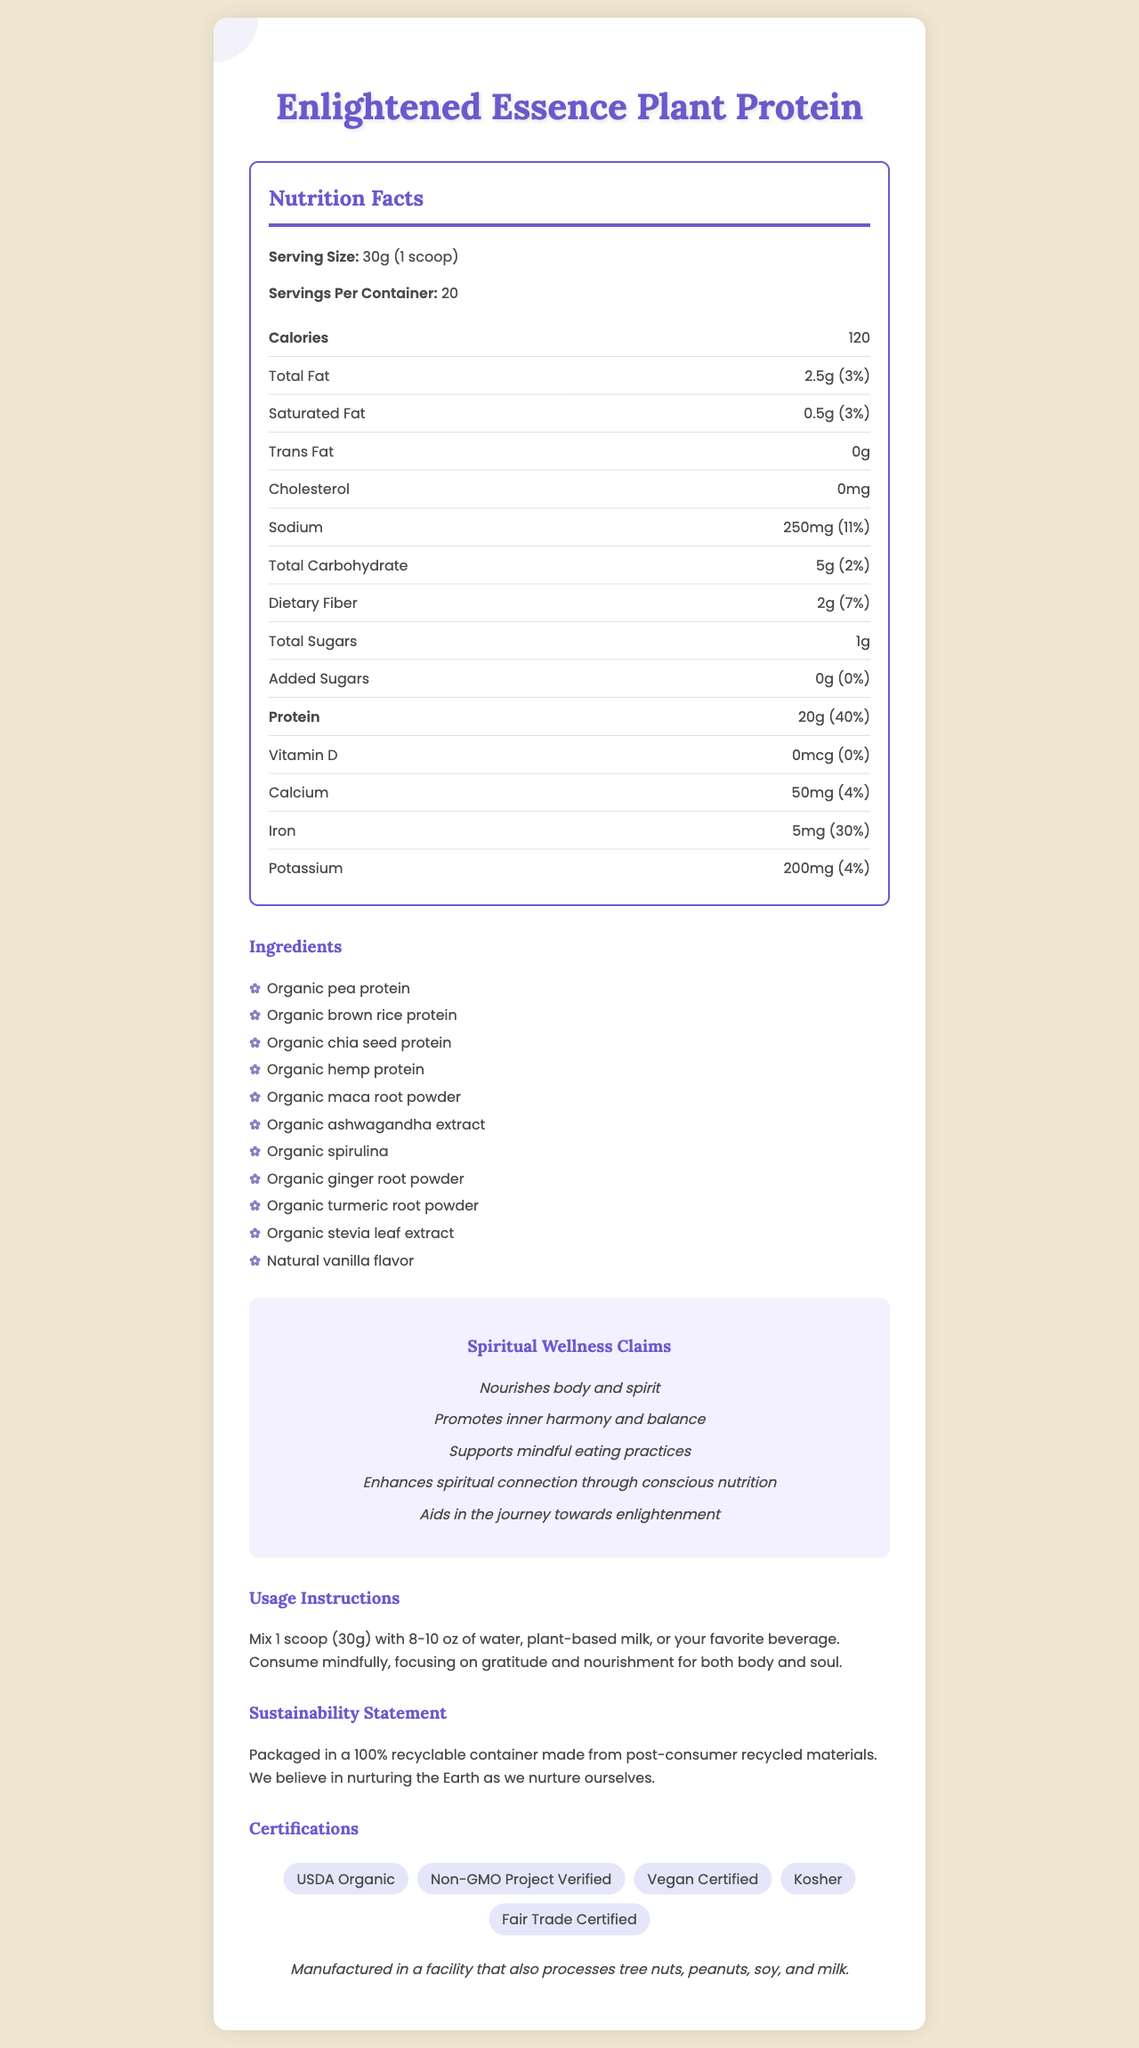what is the serving size for Enlightened Essence Plant Protein? The serving size is explicitly mentioned as "30g (1 scoop)" in the document.
Answer: 30g (1 scoop) how many servings are in one container? The document states "Servings Per Container: 20".
Answer: 20 servings what is the total fat content per serving? Under the Nutrition Facts section, it is listed that the total fat amount per serving is "2.5g (3%)".
Answer: 2.5g how much protein does one serving contain? The document specifies that one serving contains "20g (40%)" of protein.
Answer: 20g list three main protein sources in this product. The document lists the ingredients, and these are the first three protein sources mentioned.
Answer: Organic pea protein, Organic brown rice protein, Organic chia seed protein what is the daily value percentage for saturated fat? The Nutrition Facts section lists the daily value for saturated fat as "3%".
Answer: 3% how does the Enlightened Essence Plant Protein support spiritual wellness? The Spiritual Wellness Claims section lists these benefits.
Answer: Nourishes body and spirit, Promotes inner harmony and balance, Supports mindful eating practices, Enhances spiritual connection through conscious nutrition, Aids in the journey towards enlightenment what is the sodium content in one serving? The Nutrition Facts section lists the sodium content as "250mg (11%)".
Answer: 250mg which of the following certifications does the product have? A. USDA Organic B. Gluten-Free C. Fair Trade Certified D. Kosher The document lists "USDA Organic", "Fair Trade Certified", and "Kosher" under Certification Seals. Gluten-Free is not listed.
Answer: A, C, D is this product suitable for vegan diets? The Certification Seals section includes "Vegan Certified", indicating its suitability for vegan diets.
Answer: Yes describe the usage instructions for this product. The Usage Instructions section provides these detailed steps on how to prepare and consume the product.
Answer: Mix 1 scoop (30g) with 8-10 oz of water, plant-based milk, or your favorite beverage. Consume mindfully, focusing on gratitude and nourishment for both body and soul. does this product contain any added sugars? The Nutrition Facts section lists "Added Sugars: 0g (0%)", meaning there are no added sugars in the product.
Answer: No summarize the main features and benefits of the Enlightened Essence Plant Protein. This summary captures the key points on nutrition, ingredients, spiritual benefits, certifications, usage, and sustainability from the document.
Answer: Enlightened Essence Plant Protein is a plant-based protein powder with a serving size of 30g (1 scoop), containing 20 servings per container. Each serving provides 20g of protein, 2.5g of fat, 5g of carbohydrates, and various trace minerals. The ingredients include organic sources like pea protein, brown rice protein, and various functional herbs and spices. The product claims to nourish both body and spirit, promoting inner harmony and mindful eating. It is certified organic, vegan, non-GMO, kosher, and fair trade. Sustainability is emphasized, with the product packaged in recyclable materials. how many calories are in one serving of the product? The Nutrition Facts section lists the calorie content per serving as "120".
Answer: 120 calories can the document be used to determine the daily fiber intake percentage provided per serving? The Nutrition Facts section lists "Dietary Fiber: 2g (7%)", which indicates the daily fiber intake percentage per serving.
Answer: Yes, 7% how many grams of carbohydrates are in one serving? A. 2g B. 5g C. 10g D. 20g The Nutritional Facts section lists "Total Carbohydrate: 5g".
Answer: B, 5g what are the spiritual wellness claims made by the product? A. Nourishes body and spirit B. Promotes inner harmony and balance C. Enhances physical strength D. Supports mindful eating practices E. Aids in the journey towards enlightenment The Spiritual Wellness Claims section lists these specific claims.
Answer: A, B, D, E are there any potential allergens mentioned for this product? The Allergen Information section notes that the product is manufactured in a facility that also processes tree nuts, peanuts, soy, and milk.
Answer: Yes does this document provide the exact amount of Vitamin D per serving? The Nutrition Facts section lists "Vitamin D: 0mcg (0%)".
Answer: Yes, 0mcg how is the product packaged to support sustainability? The Sustainability Statement provides this packaging detail.
Answer: Packaged in a 100% recyclable container made from post-consumer recycled materials which of the ingredients in this product are root-based? The Ingredients section lists these root-based ingredients.
Answer: Organic ginger root powder, Organic turmeric root powder can this product aid in promoting a spiritual connection through nutrition? One of the Spiritual Wellness Claims explicitly states, "Enhances spiritual connection through conscious nutrition".
Answer: Yes 